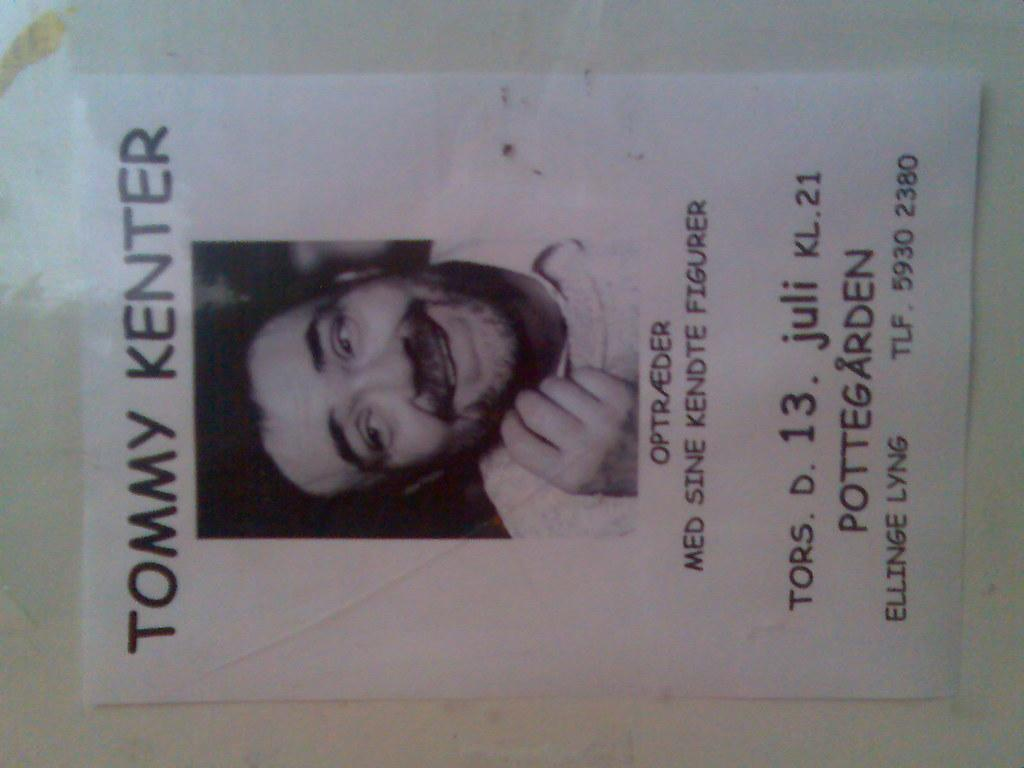<image>
Relay a brief, clear account of the picture shown. A poster with a photo of Tommy Kenter advertises an event on the 13th of July at Pottegarden. 